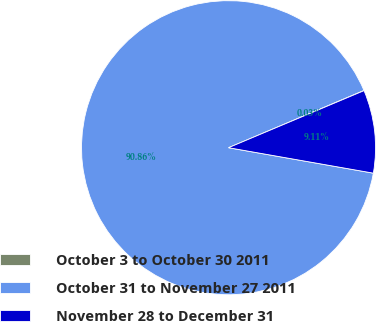Convert chart. <chart><loc_0><loc_0><loc_500><loc_500><pie_chart><fcel>October 3 to October 30 2011<fcel>October 31 to November 27 2011<fcel>November 28 to December 31<nl><fcel>0.03%<fcel>90.86%<fcel>9.11%<nl></chart> 